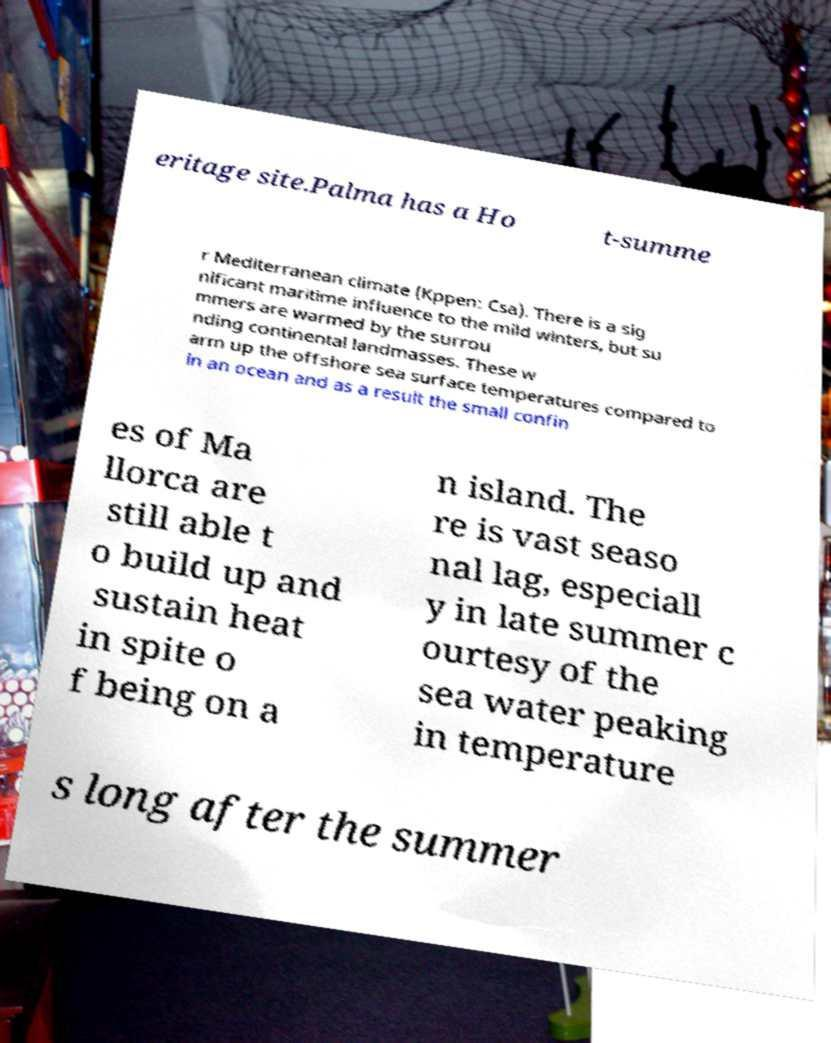There's text embedded in this image that I need extracted. Can you transcribe it verbatim? eritage site.Palma has a Ho t-summe r Mediterranean climate (Kppen: Csa). There is a sig nificant maritime influence to the mild winters, but su mmers are warmed by the surrou nding continental landmasses. These w arm up the offshore sea surface temperatures compared to in an ocean and as a result the small confin es of Ma llorca are still able t o build up and sustain heat in spite o f being on a n island. The re is vast seaso nal lag, especiall y in late summer c ourtesy of the sea water peaking in temperature s long after the summer 